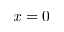<formula> <loc_0><loc_0><loc_500><loc_500>x = 0</formula> 